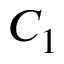Convert formula to latex. <formula><loc_0><loc_0><loc_500><loc_500>C _ { 1 }</formula> 